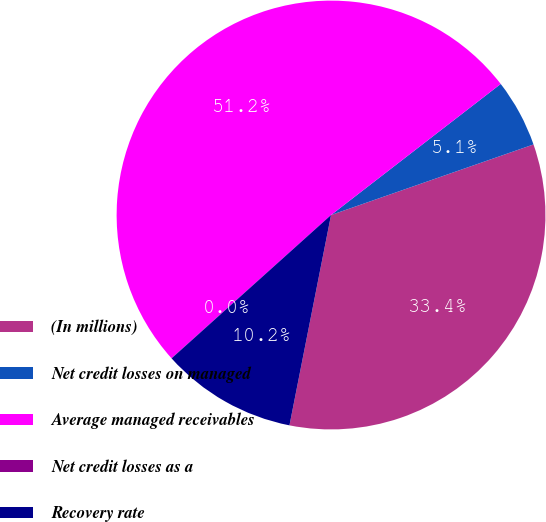<chart> <loc_0><loc_0><loc_500><loc_500><pie_chart><fcel>(In millions)<fcel>Net credit losses on managed<fcel>Average managed receivables<fcel>Net credit losses as a<fcel>Recovery rate<nl><fcel>33.44%<fcel>5.13%<fcel>51.17%<fcel>0.01%<fcel>10.24%<nl></chart> 